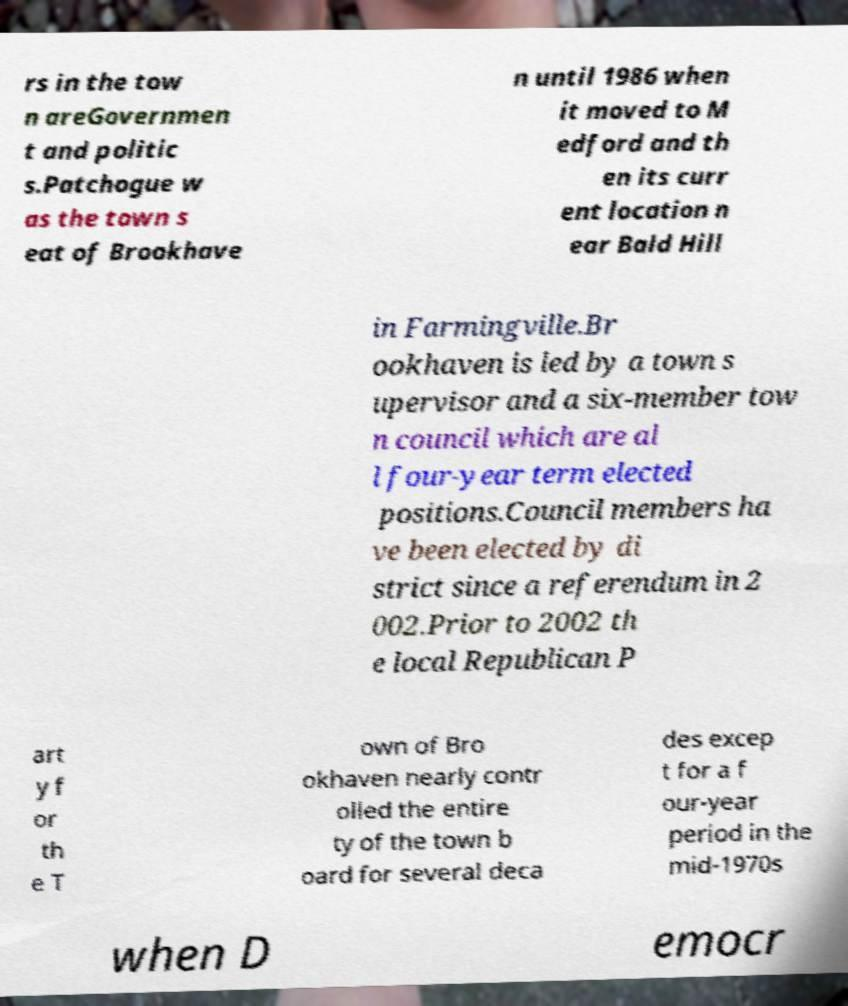Can you accurately transcribe the text from the provided image for me? rs in the tow n areGovernmen t and politic s.Patchogue w as the town s eat of Brookhave n until 1986 when it moved to M edford and th en its curr ent location n ear Bald Hill in Farmingville.Br ookhaven is led by a town s upervisor and a six-member tow n council which are al l four-year term elected positions.Council members ha ve been elected by di strict since a referendum in 2 002.Prior to 2002 th e local Republican P art y f or th e T own of Bro okhaven nearly contr olled the entire ty of the town b oard for several deca des excep t for a f our-year period in the mid-1970s when D emocr 